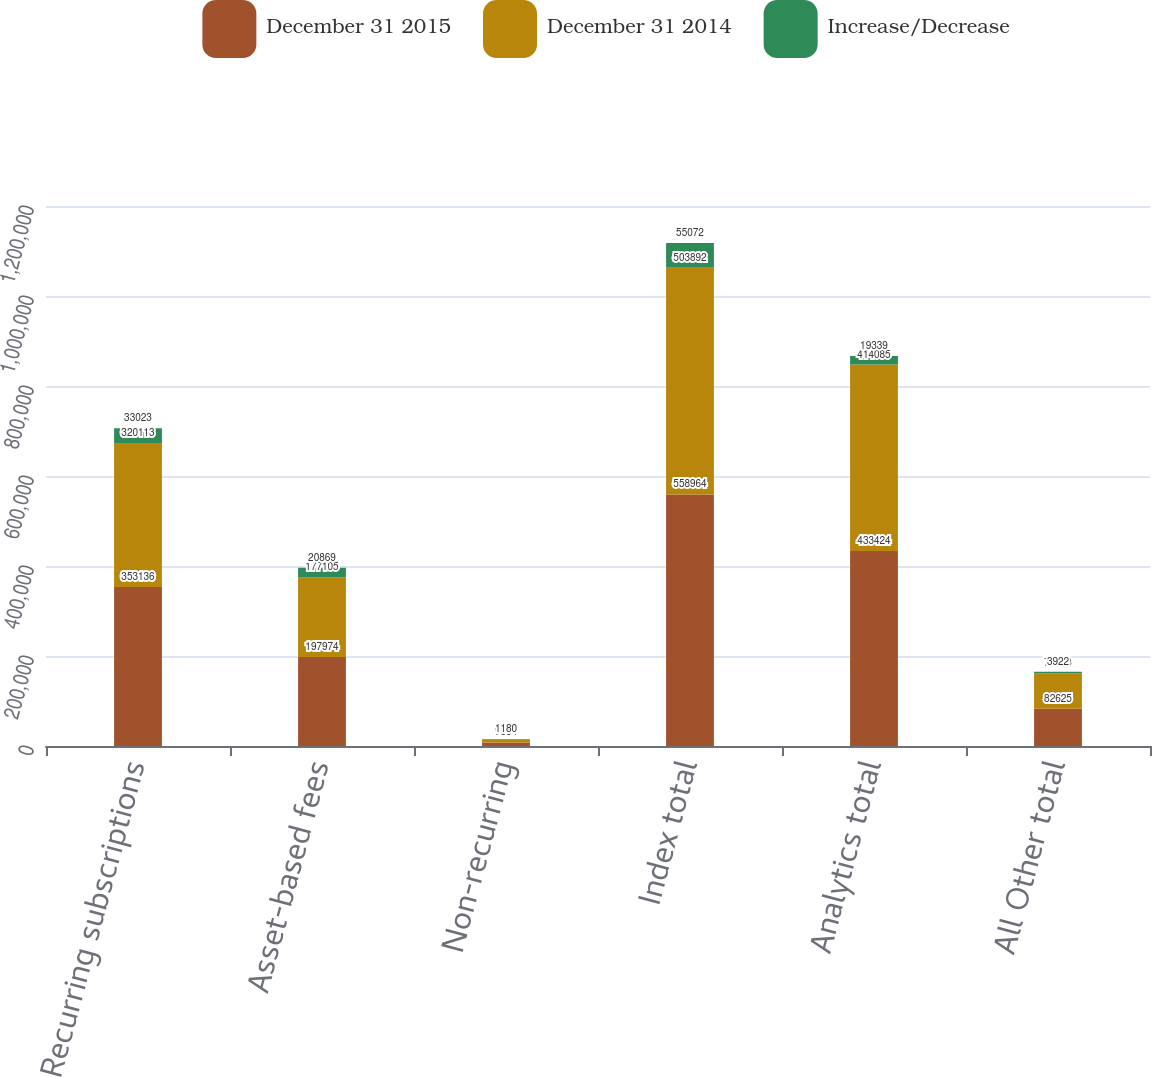Convert chart to OTSL. <chart><loc_0><loc_0><loc_500><loc_500><stacked_bar_chart><ecel><fcel>Recurring subscriptions<fcel>Asset-based fees<fcel>Non-recurring<fcel>Index total<fcel>Analytics total<fcel>All Other total<nl><fcel>December 31 2015<fcel>353136<fcel>197974<fcel>7854<fcel>558964<fcel>433424<fcel>82625<nl><fcel>December 31 2014<fcel>320113<fcel>177105<fcel>6674<fcel>503892<fcel>414085<fcel>78703<nl><fcel>Increase/Decrease<fcel>33023<fcel>20869<fcel>1180<fcel>55072<fcel>19339<fcel>3922<nl></chart> 